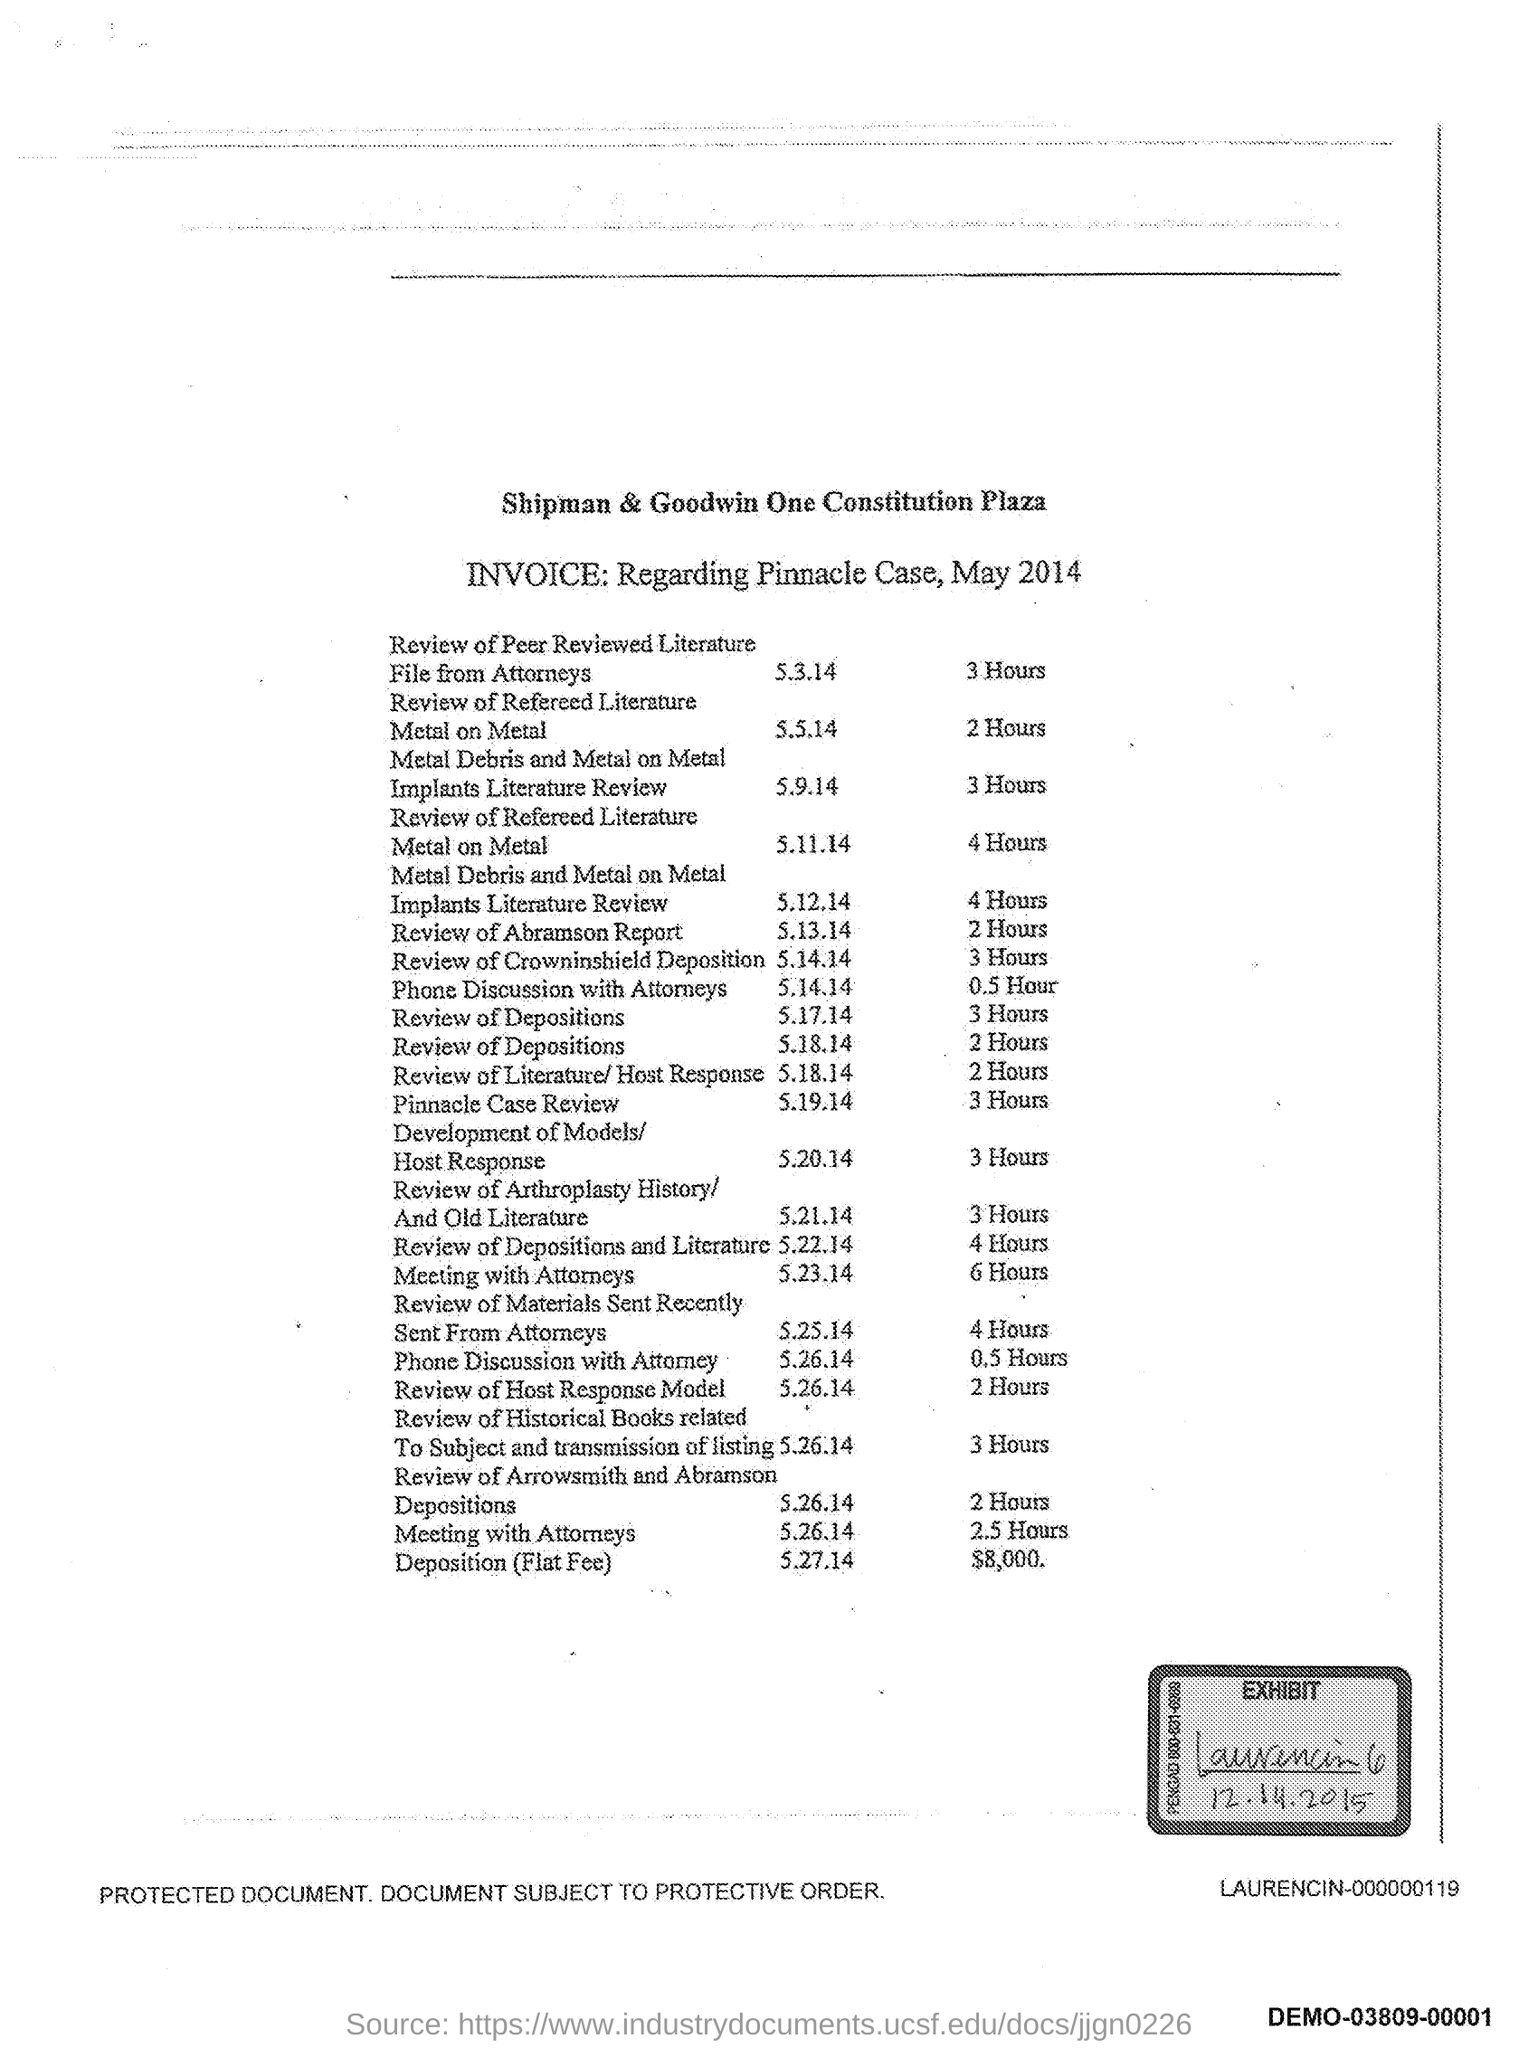Outline some significant characteristics in this image. The time mentioned for the meeting with the attorneys is 2.5 hours. The invoice is in relation to the Pinnacle Case, which occurred in May 2014. The review of the Crowninshield Deposition was held on May 14th, 2014. The exhibit date listed in the document is 12.14.2015. The time mentioned for the review of the Abramson report is 2 hours. 